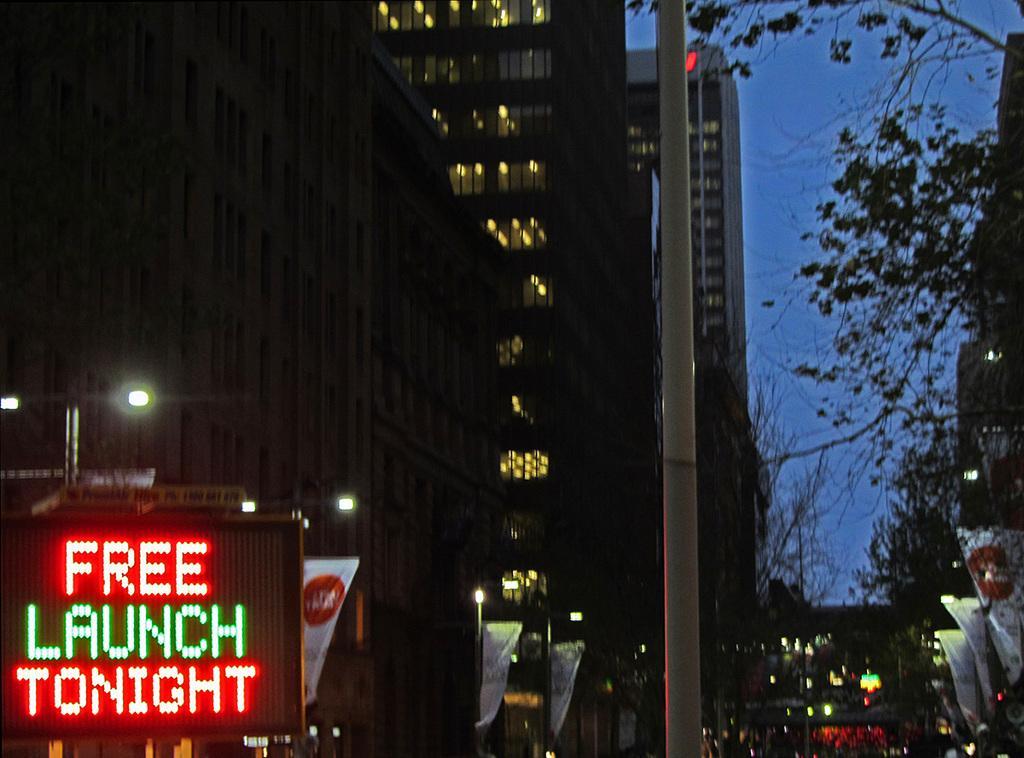Describe this image in one or two sentences. In this image, we can see a few buildings, street lights, banners, trees, poles, digital screen. On the right side background, we can see the sky. 